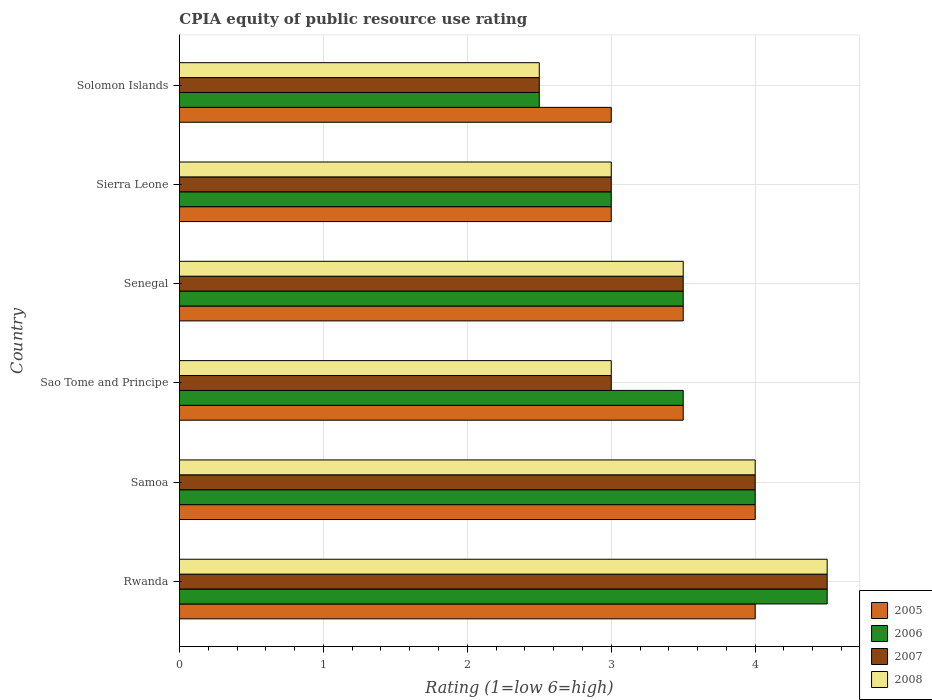How many groups of bars are there?
Make the answer very short. 6. Are the number of bars on each tick of the Y-axis equal?
Your response must be concise. Yes. How many bars are there on the 2nd tick from the top?
Make the answer very short. 4. How many bars are there on the 1st tick from the bottom?
Provide a succinct answer. 4. What is the label of the 6th group of bars from the top?
Offer a terse response. Rwanda. What is the CPIA rating in 2005 in Samoa?
Make the answer very short. 4. In which country was the CPIA rating in 2008 maximum?
Your answer should be compact. Rwanda. In which country was the CPIA rating in 2008 minimum?
Keep it short and to the point. Solomon Islands. What is the total CPIA rating in 2008 in the graph?
Ensure brevity in your answer.  20.5. What is the difference between the CPIA rating in 2006 in Sao Tome and Principe and that in Sierra Leone?
Offer a terse response. 0.5. What is the difference between the CPIA rating in 2006 in Rwanda and the CPIA rating in 2008 in Senegal?
Your answer should be compact. 1. What is the average CPIA rating in 2008 per country?
Your answer should be very brief. 3.42. What is the difference between the CPIA rating in 2007 and CPIA rating in 2005 in Sierra Leone?
Give a very brief answer. 0. In how many countries, is the CPIA rating in 2005 greater than 2.8 ?
Make the answer very short. 6. Is the difference between the CPIA rating in 2007 in Sao Tome and Principe and Solomon Islands greater than the difference between the CPIA rating in 2005 in Sao Tome and Principe and Solomon Islands?
Give a very brief answer. No. What is the difference between the highest and the lowest CPIA rating in 2008?
Make the answer very short. 2. Is the sum of the CPIA rating in 2005 in Rwanda and Sierra Leone greater than the maximum CPIA rating in 2007 across all countries?
Your answer should be very brief. Yes. Is it the case that in every country, the sum of the CPIA rating in 2005 and CPIA rating in 2008 is greater than the sum of CPIA rating in 2006 and CPIA rating in 2007?
Offer a very short reply. No. What does the 4th bar from the bottom in Sierra Leone represents?
Keep it short and to the point. 2008. How many countries are there in the graph?
Your answer should be compact. 6. Does the graph contain any zero values?
Ensure brevity in your answer.  No. Where does the legend appear in the graph?
Ensure brevity in your answer.  Bottom right. How are the legend labels stacked?
Ensure brevity in your answer.  Vertical. What is the title of the graph?
Ensure brevity in your answer.  CPIA equity of public resource use rating. Does "2013" appear as one of the legend labels in the graph?
Your answer should be compact. No. What is the Rating (1=low 6=high) of 2006 in Rwanda?
Your answer should be very brief. 4.5. What is the Rating (1=low 6=high) in 2007 in Rwanda?
Your answer should be very brief. 4.5. What is the Rating (1=low 6=high) in 2008 in Samoa?
Your response must be concise. 4. What is the Rating (1=low 6=high) of 2006 in Sao Tome and Principe?
Offer a terse response. 3.5. What is the Rating (1=low 6=high) of 2007 in Sao Tome and Principe?
Ensure brevity in your answer.  3. What is the Rating (1=low 6=high) of 2005 in Sierra Leone?
Make the answer very short. 3. What is the Rating (1=low 6=high) of 2008 in Sierra Leone?
Ensure brevity in your answer.  3. What is the Rating (1=low 6=high) in 2007 in Solomon Islands?
Your answer should be compact. 2.5. What is the Rating (1=low 6=high) in 2008 in Solomon Islands?
Your response must be concise. 2.5. Across all countries, what is the minimum Rating (1=low 6=high) of 2005?
Ensure brevity in your answer.  3. Across all countries, what is the minimum Rating (1=low 6=high) of 2006?
Offer a terse response. 2.5. Across all countries, what is the minimum Rating (1=low 6=high) in 2008?
Your response must be concise. 2.5. What is the difference between the Rating (1=low 6=high) of 2005 in Rwanda and that in Samoa?
Keep it short and to the point. 0. What is the difference between the Rating (1=low 6=high) in 2007 in Rwanda and that in Samoa?
Ensure brevity in your answer.  0.5. What is the difference between the Rating (1=low 6=high) in 2008 in Rwanda and that in Samoa?
Give a very brief answer. 0.5. What is the difference between the Rating (1=low 6=high) of 2007 in Rwanda and that in Sao Tome and Principe?
Give a very brief answer. 1.5. What is the difference between the Rating (1=low 6=high) in 2008 in Rwanda and that in Senegal?
Your answer should be compact. 1. What is the difference between the Rating (1=low 6=high) in 2005 in Rwanda and that in Sierra Leone?
Your answer should be compact. 1. What is the difference between the Rating (1=low 6=high) in 2006 in Rwanda and that in Sierra Leone?
Offer a terse response. 1.5. What is the difference between the Rating (1=low 6=high) of 2007 in Rwanda and that in Sierra Leone?
Ensure brevity in your answer.  1.5. What is the difference between the Rating (1=low 6=high) of 2008 in Rwanda and that in Sierra Leone?
Give a very brief answer. 1.5. What is the difference between the Rating (1=low 6=high) in 2006 in Rwanda and that in Solomon Islands?
Your answer should be very brief. 2. What is the difference between the Rating (1=low 6=high) of 2007 in Rwanda and that in Solomon Islands?
Give a very brief answer. 2. What is the difference between the Rating (1=low 6=high) in 2005 in Samoa and that in Sao Tome and Principe?
Your response must be concise. 0.5. What is the difference between the Rating (1=low 6=high) in 2006 in Samoa and that in Sao Tome and Principe?
Give a very brief answer. 0.5. What is the difference between the Rating (1=low 6=high) of 2008 in Samoa and that in Sao Tome and Principe?
Offer a terse response. 1. What is the difference between the Rating (1=low 6=high) in 2008 in Samoa and that in Senegal?
Provide a succinct answer. 0.5. What is the difference between the Rating (1=low 6=high) of 2005 in Samoa and that in Sierra Leone?
Your response must be concise. 1. What is the difference between the Rating (1=low 6=high) of 2006 in Samoa and that in Sierra Leone?
Your response must be concise. 1. What is the difference between the Rating (1=low 6=high) in 2007 in Samoa and that in Sierra Leone?
Provide a succinct answer. 1. What is the difference between the Rating (1=low 6=high) in 2008 in Samoa and that in Sierra Leone?
Your answer should be very brief. 1. What is the difference between the Rating (1=low 6=high) in 2005 in Samoa and that in Solomon Islands?
Provide a short and direct response. 1. What is the difference between the Rating (1=low 6=high) of 2007 in Samoa and that in Solomon Islands?
Provide a short and direct response. 1.5. What is the difference between the Rating (1=low 6=high) of 2005 in Sao Tome and Principe and that in Senegal?
Provide a succinct answer. 0. What is the difference between the Rating (1=low 6=high) of 2007 in Sao Tome and Principe and that in Senegal?
Your answer should be compact. -0.5. What is the difference between the Rating (1=low 6=high) of 2007 in Sao Tome and Principe and that in Sierra Leone?
Provide a succinct answer. 0. What is the difference between the Rating (1=low 6=high) in 2005 in Sao Tome and Principe and that in Solomon Islands?
Make the answer very short. 0.5. What is the difference between the Rating (1=low 6=high) in 2007 in Sao Tome and Principe and that in Solomon Islands?
Give a very brief answer. 0.5. What is the difference between the Rating (1=low 6=high) of 2008 in Sao Tome and Principe and that in Solomon Islands?
Offer a very short reply. 0.5. What is the difference between the Rating (1=low 6=high) in 2005 in Senegal and that in Sierra Leone?
Provide a succinct answer. 0.5. What is the difference between the Rating (1=low 6=high) in 2006 in Senegal and that in Sierra Leone?
Give a very brief answer. 0.5. What is the difference between the Rating (1=low 6=high) of 2007 in Senegal and that in Sierra Leone?
Provide a short and direct response. 0.5. What is the difference between the Rating (1=low 6=high) in 2008 in Senegal and that in Solomon Islands?
Offer a very short reply. 1. What is the difference between the Rating (1=low 6=high) in 2006 in Sierra Leone and that in Solomon Islands?
Your answer should be compact. 0.5. What is the difference between the Rating (1=low 6=high) in 2007 in Sierra Leone and that in Solomon Islands?
Your answer should be very brief. 0.5. What is the difference between the Rating (1=low 6=high) in 2008 in Sierra Leone and that in Solomon Islands?
Provide a succinct answer. 0.5. What is the difference between the Rating (1=low 6=high) in 2005 in Rwanda and the Rating (1=low 6=high) in 2006 in Samoa?
Provide a succinct answer. 0. What is the difference between the Rating (1=low 6=high) of 2006 in Rwanda and the Rating (1=low 6=high) of 2007 in Samoa?
Offer a terse response. 0.5. What is the difference between the Rating (1=low 6=high) in 2006 in Rwanda and the Rating (1=low 6=high) in 2008 in Samoa?
Ensure brevity in your answer.  0.5. What is the difference between the Rating (1=low 6=high) in 2006 in Rwanda and the Rating (1=low 6=high) in 2008 in Sao Tome and Principe?
Give a very brief answer. 1.5. What is the difference between the Rating (1=low 6=high) in 2007 in Rwanda and the Rating (1=low 6=high) in 2008 in Sao Tome and Principe?
Keep it short and to the point. 1.5. What is the difference between the Rating (1=low 6=high) of 2005 in Rwanda and the Rating (1=low 6=high) of 2006 in Senegal?
Offer a very short reply. 0.5. What is the difference between the Rating (1=low 6=high) in 2006 in Rwanda and the Rating (1=low 6=high) in 2007 in Senegal?
Offer a terse response. 1. What is the difference between the Rating (1=low 6=high) in 2006 in Rwanda and the Rating (1=low 6=high) in 2008 in Senegal?
Your answer should be compact. 1. What is the difference between the Rating (1=low 6=high) of 2005 in Rwanda and the Rating (1=low 6=high) of 2006 in Sierra Leone?
Provide a short and direct response. 1. What is the difference between the Rating (1=low 6=high) of 2005 in Rwanda and the Rating (1=low 6=high) of 2008 in Sierra Leone?
Your answer should be compact. 1. What is the difference between the Rating (1=low 6=high) of 2007 in Rwanda and the Rating (1=low 6=high) of 2008 in Solomon Islands?
Give a very brief answer. 2. What is the difference between the Rating (1=low 6=high) in 2005 in Samoa and the Rating (1=low 6=high) in 2006 in Sao Tome and Principe?
Your answer should be compact. 0.5. What is the difference between the Rating (1=low 6=high) of 2005 in Samoa and the Rating (1=low 6=high) of 2008 in Sao Tome and Principe?
Provide a succinct answer. 1. What is the difference between the Rating (1=low 6=high) of 2006 in Samoa and the Rating (1=low 6=high) of 2007 in Sao Tome and Principe?
Ensure brevity in your answer.  1. What is the difference between the Rating (1=low 6=high) of 2006 in Samoa and the Rating (1=low 6=high) of 2008 in Sao Tome and Principe?
Make the answer very short. 1. What is the difference between the Rating (1=low 6=high) in 2007 in Samoa and the Rating (1=low 6=high) in 2008 in Sao Tome and Principe?
Offer a terse response. 1. What is the difference between the Rating (1=low 6=high) in 2005 in Samoa and the Rating (1=low 6=high) in 2006 in Senegal?
Offer a terse response. 0.5. What is the difference between the Rating (1=low 6=high) of 2006 in Samoa and the Rating (1=low 6=high) of 2007 in Sierra Leone?
Make the answer very short. 1. What is the difference between the Rating (1=low 6=high) in 2007 in Samoa and the Rating (1=low 6=high) in 2008 in Sierra Leone?
Offer a very short reply. 1. What is the difference between the Rating (1=low 6=high) of 2005 in Samoa and the Rating (1=low 6=high) of 2007 in Solomon Islands?
Offer a very short reply. 1.5. What is the difference between the Rating (1=low 6=high) of 2005 in Samoa and the Rating (1=low 6=high) of 2008 in Solomon Islands?
Offer a very short reply. 1.5. What is the difference between the Rating (1=low 6=high) in 2006 in Samoa and the Rating (1=low 6=high) in 2007 in Solomon Islands?
Make the answer very short. 1.5. What is the difference between the Rating (1=low 6=high) in 2005 in Sao Tome and Principe and the Rating (1=low 6=high) in 2006 in Senegal?
Provide a succinct answer. 0. What is the difference between the Rating (1=low 6=high) of 2005 in Sao Tome and Principe and the Rating (1=low 6=high) of 2008 in Senegal?
Offer a terse response. 0. What is the difference between the Rating (1=low 6=high) of 2006 in Sao Tome and Principe and the Rating (1=low 6=high) of 2007 in Senegal?
Offer a terse response. 0. What is the difference between the Rating (1=low 6=high) of 2005 in Sao Tome and Principe and the Rating (1=low 6=high) of 2007 in Sierra Leone?
Provide a succinct answer. 0.5. What is the difference between the Rating (1=low 6=high) in 2005 in Sao Tome and Principe and the Rating (1=low 6=high) in 2008 in Sierra Leone?
Your answer should be compact. 0.5. What is the difference between the Rating (1=low 6=high) in 2006 in Sao Tome and Principe and the Rating (1=low 6=high) in 2007 in Sierra Leone?
Provide a short and direct response. 0.5. What is the difference between the Rating (1=low 6=high) in 2007 in Sao Tome and Principe and the Rating (1=low 6=high) in 2008 in Sierra Leone?
Make the answer very short. 0. What is the difference between the Rating (1=low 6=high) of 2005 in Sao Tome and Principe and the Rating (1=low 6=high) of 2006 in Solomon Islands?
Ensure brevity in your answer.  1. What is the difference between the Rating (1=low 6=high) of 2005 in Sao Tome and Principe and the Rating (1=low 6=high) of 2007 in Solomon Islands?
Your answer should be very brief. 1. What is the difference between the Rating (1=low 6=high) in 2005 in Sao Tome and Principe and the Rating (1=low 6=high) in 2008 in Solomon Islands?
Your answer should be compact. 1. What is the difference between the Rating (1=low 6=high) in 2006 in Sao Tome and Principe and the Rating (1=low 6=high) in 2008 in Solomon Islands?
Your response must be concise. 1. What is the difference between the Rating (1=low 6=high) in 2007 in Sao Tome and Principe and the Rating (1=low 6=high) in 2008 in Solomon Islands?
Provide a short and direct response. 0.5. What is the difference between the Rating (1=low 6=high) in 2007 in Senegal and the Rating (1=low 6=high) in 2008 in Sierra Leone?
Offer a very short reply. 0.5. What is the difference between the Rating (1=low 6=high) of 2005 in Senegal and the Rating (1=low 6=high) of 2006 in Solomon Islands?
Your response must be concise. 1. What is the difference between the Rating (1=low 6=high) of 2005 in Senegal and the Rating (1=low 6=high) of 2008 in Solomon Islands?
Give a very brief answer. 1. What is the difference between the Rating (1=low 6=high) in 2006 in Senegal and the Rating (1=low 6=high) in 2007 in Solomon Islands?
Ensure brevity in your answer.  1. What is the difference between the Rating (1=low 6=high) in 2006 in Senegal and the Rating (1=low 6=high) in 2008 in Solomon Islands?
Give a very brief answer. 1. What is the difference between the Rating (1=low 6=high) in 2007 in Senegal and the Rating (1=low 6=high) in 2008 in Solomon Islands?
Make the answer very short. 1. What is the difference between the Rating (1=low 6=high) of 2005 in Sierra Leone and the Rating (1=low 6=high) of 2006 in Solomon Islands?
Your response must be concise. 0.5. What is the difference between the Rating (1=low 6=high) of 2005 in Sierra Leone and the Rating (1=low 6=high) of 2007 in Solomon Islands?
Make the answer very short. 0.5. What is the difference between the Rating (1=low 6=high) in 2005 in Sierra Leone and the Rating (1=low 6=high) in 2008 in Solomon Islands?
Make the answer very short. 0.5. What is the average Rating (1=low 6=high) of 2007 per country?
Keep it short and to the point. 3.42. What is the average Rating (1=low 6=high) in 2008 per country?
Offer a very short reply. 3.42. What is the difference between the Rating (1=low 6=high) of 2005 and Rating (1=low 6=high) of 2006 in Rwanda?
Your answer should be very brief. -0.5. What is the difference between the Rating (1=low 6=high) in 2005 and Rating (1=low 6=high) in 2008 in Rwanda?
Offer a terse response. -0.5. What is the difference between the Rating (1=low 6=high) in 2007 and Rating (1=low 6=high) in 2008 in Rwanda?
Ensure brevity in your answer.  0. What is the difference between the Rating (1=low 6=high) in 2005 and Rating (1=low 6=high) in 2006 in Samoa?
Your response must be concise. 0. What is the difference between the Rating (1=low 6=high) of 2005 and Rating (1=low 6=high) of 2007 in Samoa?
Provide a succinct answer. 0. What is the difference between the Rating (1=low 6=high) of 2007 and Rating (1=low 6=high) of 2008 in Samoa?
Provide a short and direct response. 0. What is the difference between the Rating (1=low 6=high) of 2005 and Rating (1=low 6=high) of 2006 in Sao Tome and Principe?
Give a very brief answer. 0. What is the difference between the Rating (1=low 6=high) in 2007 and Rating (1=low 6=high) in 2008 in Sao Tome and Principe?
Give a very brief answer. 0. What is the difference between the Rating (1=low 6=high) of 2005 and Rating (1=low 6=high) of 2007 in Senegal?
Your response must be concise. 0. What is the difference between the Rating (1=low 6=high) in 2005 and Rating (1=low 6=high) in 2008 in Senegal?
Ensure brevity in your answer.  0. What is the difference between the Rating (1=low 6=high) of 2006 and Rating (1=low 6=high) of 2007 in Senegal?
Offer a very short reply. 0. What is the difference between the Rating (1=low 6=high) in 2007 and Rating (1=low 6=high) in 2008 in Senegal?
Provide a short and direct response. 0. What is the difference between the Rating (1=low 6=high) in 2005 and Rating (1=low 6=high) in 2006 in Sierra Leone?
Offer a terse response. 0. What is the difference between the Rating (1=low 6=high) in 2005 and Rating (1=low 6=high) in 2007 in Sierra Leone?
Offer a terse response. 0. What is the difference between the Rating (1=low 6=high) of 2005 and Rating (1=low 6=high) of 2008 in Sierra Leone?
Provide a short and direct response. 0. What is the difference between the Rating (1=low 6=high) in 2006 and Rating (1=low 6=high) in 2007 in Sierra Leone?
Your answer should be compact. 0. What is the difference between the Rating (1=low 6=high) of 2006 and Rating (1=low 6=high) of 2008 in Sierra Leone?
Your answer should be compact. 0. What is the difference between the Rating (1=low 6=high) of 2005 and Rating (1=low 6=high) of 2007 in Solomon Islands?
Provide a succinct answer. 0.5. What is the difference between the Rating (1=low 6=high) in 2006 and Rating (1=low 6=high) in 2008 in Solomon Islands?
Keep it short and to the point. 0. What is the difference between the Rating (1=low 6=high) in 2007 and Rating (1=low 6=high) in 2008 in Solomon Islands?
Give a very brief answer. 0. What is the ratio of the Rating (1=low 6=high) of 2006 in Rwanda to that in Samoa?
Give a very brief answer. 1.12. What is the ratio of the Rating (1=low 6=high) in 2005 in Rwanda to that in Sao Tome and Principe?
Offer a very short reply. 1.14. What is the ratio of the Rating (1=low 6=high) of 2008 in Rwanda to that in Sao Tome and Principe?
Ensure brevity in your answer.  1.5. What is the ratio of the Rating (1=low 6=high) of 2006 in Rwanda to that in Senegal?
Your answer should be compact. 1.29. What is the ratio of the Rating (1=low 6=high) of 2007 in Rwanda to that in Senegal?
Offer a terse response. 1.29. What is the ratio of the Rating (1=low 6=high) of 2007 in Rwanda to that in Sierra Leone?
Your response must be concise. 1.5. What is the ratio of the Rating (1=low 6=high) in 2008 in Rwanda to that in Sierra Leone?
Offer a terse response. 1.5. What is the ratio of the Rating (1=low 6=high) of 2005 in Rwanda to that in Solomon Islands?
Offer a very short reply. 1.33. What is the ratio of the Rating (1=low 6=high) of 2006 in Rwanda to that in Solomon Islands?
Offer a very short reply. 1.8. What is the ratio of the Rating (1=low 6=high) in 2008 in Rwanda to that in Solomon Islands?
Give a very brief answer. 1.8. What is the ratio of the Rating (1=low 6=high) of 2005 in Samoa to that in Sao Tome and Principe?
Ensure brevity in your answer.  1.14. What is the ratio of the Rating (1=low 6=high) of 2007 in Samoa to that in Sao Tome and Principe?
Your answer should be very brief. 1.33. What is the ratio of the Rating (1=low 6=high) in 2008 in Samoa to that in Sao Tome and Principe?
Provide a short and direct response. 1.33. What is the ratio of the Rating (1=low 6=high) of 2007 in Samoa to that in Senegal?
Provide a short and direct response. 1.14. What is the ratio of the Rating (1=low 6=high) of 2008 in Samoa to that in Senegal?
Give a very brief answer. 1.14. What is the ratio of the Rating (1=low 6=high) of 2006 in Samoa to that in Sierra Leone?
Your answer should be compact. 1.33. What is the ratio of the Rating (1=low 6=high) in 2007 in Samoa to that in Sierra Leone?
Ensure brevity in your answer.  1.33. What is the ratio of the Rating (1=low 6=high) of 2008 in Samoa to that in Sierra Leone?
Offer a very short reply. 1.33. What is the ratio of the Rating (1=low 6=high) of 2008 in Samoa to that in Solomon Islands?
Provide a succinct answer. 1.6. What is the ratio of the Rating (1=low 6=high) in 2006 in Sao Tome and Principe to that in Senegal?
Your answer should be very brief. 1. What is the ratio of the Rating (1=low 6=high) of 2007 in Sao Tome and Principe to that in Senegal?
Offer a very short reply. 0.86. What is the ratio of the Rating (1=low 6=high) of 2005 in Sao Tome and Principe to that in Sierra Leone?
Ensure brevity in your answer.  1.17. What is the ratio of the Rating (1=low 6=high) of 2008 in Sao Tome and Principe to that in Sierra Leone?
Provide a succinct answer. 1. What is the ratio of the Rating (1=low 6=high) of 2005 in Sao Tome and Principe to that in Solomon Islands?
Keep it short and to the point. 1.17. What is the ratio of the Rating (1=low 6=high) of 2007 in Sao Tome and Principe to that in Solomon Islands?
Make the answer very short. 1.2. What is the ratio of the Rating (1=low 6=high) in 2005 in Senegal to that in Sierra Leone?
Give a very brief answer. 1.17. What is the ratio of the Rating (1=low 6=high) in 2006 in Senegal to that in Sierra Leone?
Provide a short and direct response. 1.17. What is the ratio of the Rating (1=low 6=high) in 2007 in Senegal to that in Solomon Islands?
Ensure brevity in your answer.  1.4. What is the ratio of the Rating (1=low 6=high) in 2005 in Sierra Leone to that in Solomon Islands?
Ensure brevity in your answer.  1. What is the difference between the highest and the second highest Rating (1=low 6=high) of 2008?
Your answer should be very brief. 0.5. What is the difference between the highest and the lowest Rating (1=low 6=high) in 2008?
Your answer should be very brief. 2. 